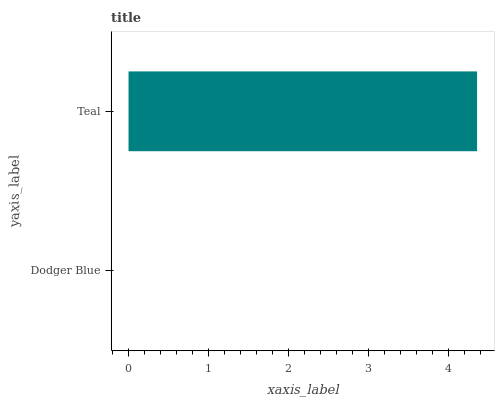Is Dodger Blue the minimum?
Answer yes or no. Yes. Is Teal the maximum?
Answer yes or no. Yes. Is Teal the minimum?
Answer yes or no. No. Is Teal greater than Dodger Blue?
Answer yes or no. Yes. Is Dodger Blue less than Teal?
Answer yes or no. Yes. Is Dodger Blue greater than Teal?
Answer yes or no. No. Is Teal less than Dodger Blue?
Answer yes or no. No. Is Teal the high median?
Answer yes or no. Yes. Is Dodger Blue the low median?
Answer yes or no. Yes. Is Dodger Blue the high median?
Answer yes or no. No. Is Teal the low median?
Answer yes or no. No. 